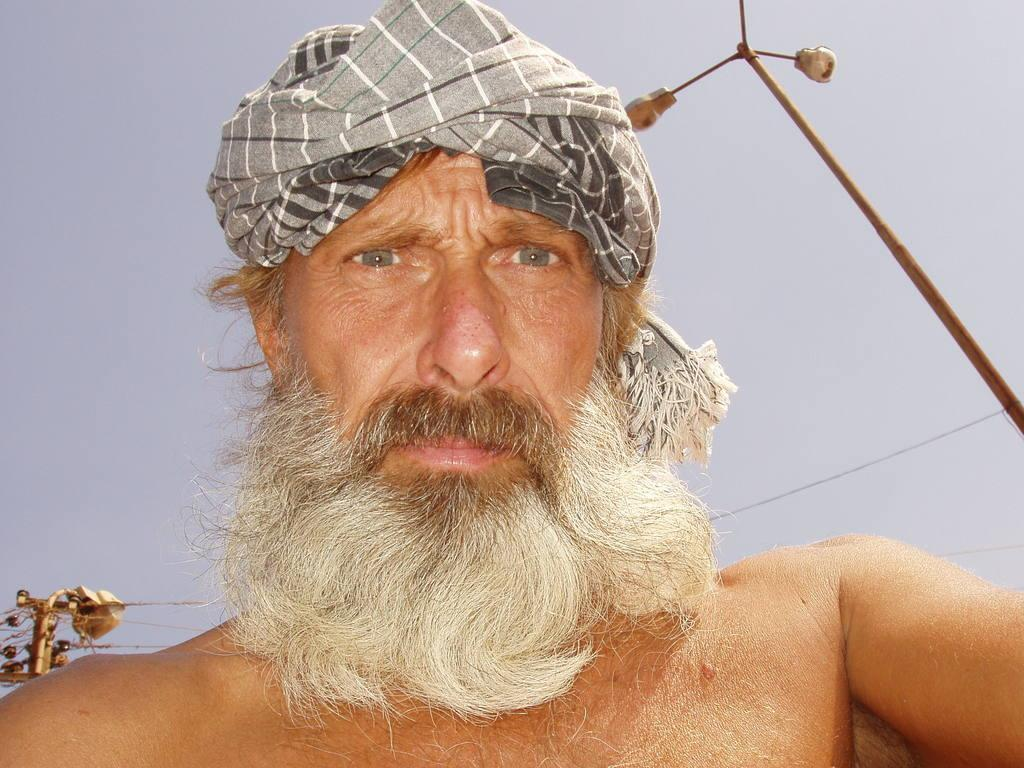What is the main subject of the image? There is a person in the image. What type of structure can be seen in the background of the image? There is an electric pole visible in the image. What part of the natural environment is visible in the image? The sky is visible in the image. What type of camera is the person using to take pictures of the giants in the image? There is no camera or giants present in the image. 